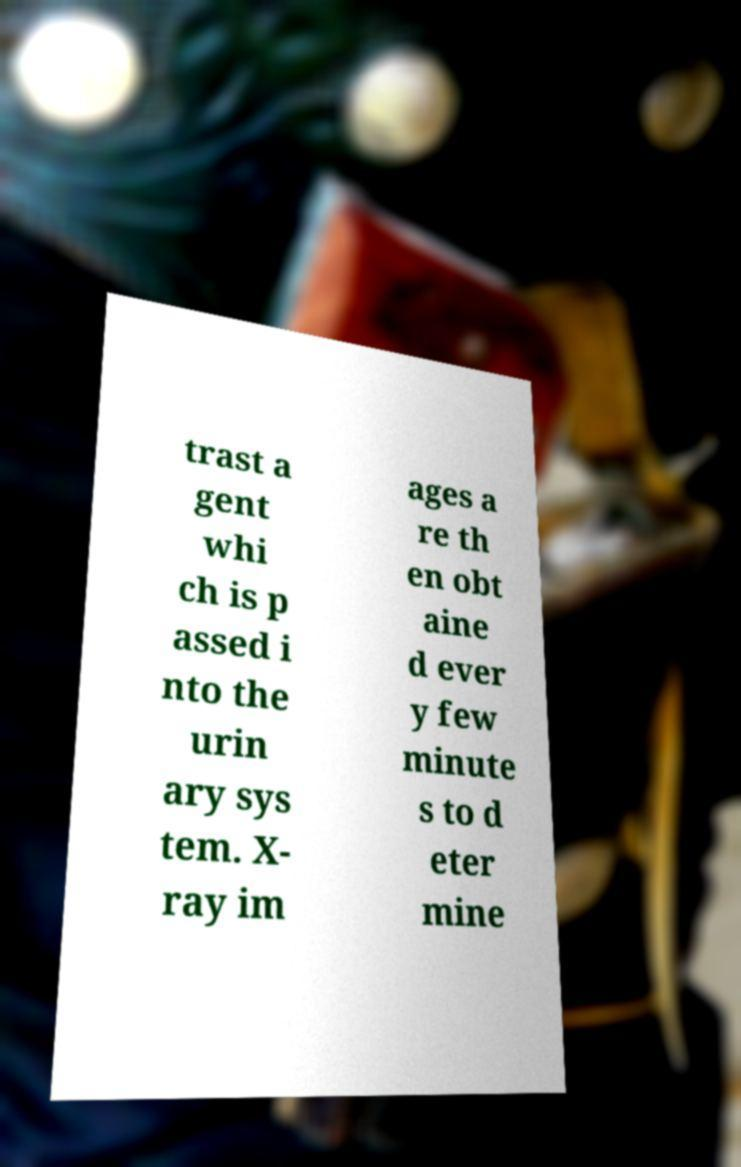What messages or text are displayed in this image? I need them in a readable, typed format. trast a gent whi ch is p assed i nto the urin ary sys tem. X- ray im ages a re th en obt aine d ever y few minute s to d eter mine 